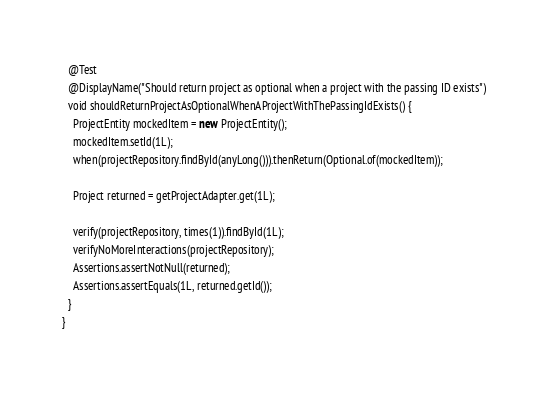<code> <loc_0><loc_0><loc_500><loc_500><_Java_>
  @Test
  @DisplayName("Should return project as optional when a project with the passing ID exists")
  void shouldReturnProjectAsOptionalWhenAProjectWithThePassingIdExists() {
    ProjectEntity mockedItem = new ProjectEntity();
    mockedItem.setId(1L);
    when(projectRepository.findById(anyLong())).thenReturn(Optional.of(mockedItem));

    Project returned = getProjectAdapter.get(1L);

    verify(projectRepository, times(1)).findById(1L);
    verifyNoMoreInteractions(projectRepository);
    Assertions.assertNotNull(returned);
    Assertions.assertEquals(1L, returned.getId());
  }
}
</code> 